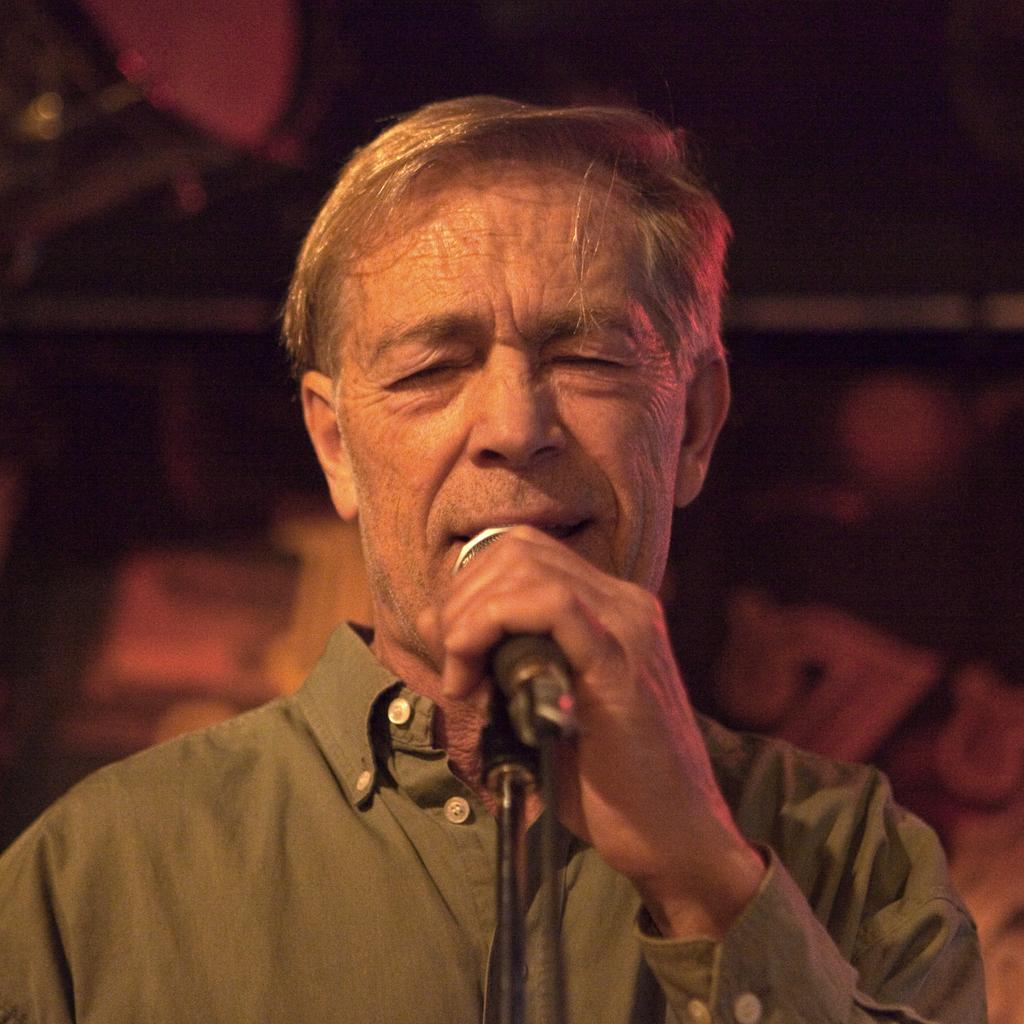Describe this image in one or two sentences. In this picture we can see man holding mic in his hand and singing and in background we can see it as dark. 